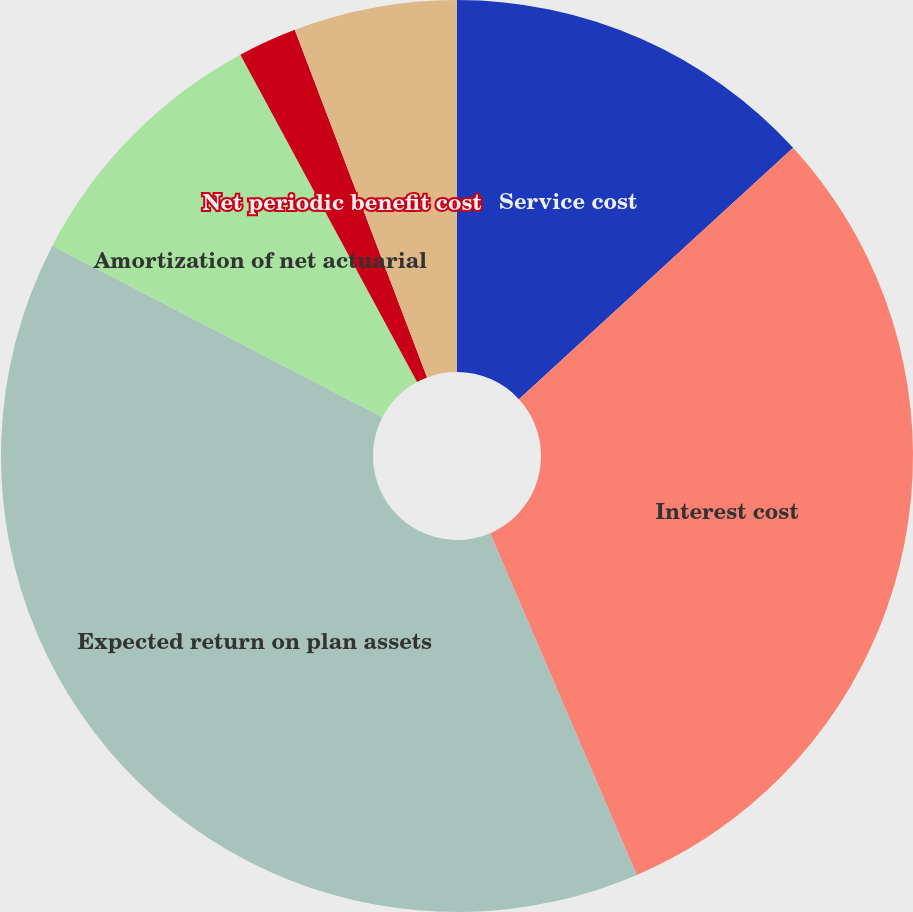Convert chart to OTSL. <chart><loc_0><loc_0><loc_500><loc_500><pie_chart><fcel>Service cost<fcel>Interest cost<fcel>Expected return on plan assets<fcel>Amortization of net actuarial<fcel>Net periodic benefit cost<fcel>Total benefit cost (income)<nl><fcel>13.19%<fcel>30.36%<fcel>39.08%<fcel>9.49%<fcel>2.09%<fcel>5.79%<nl></chart> 